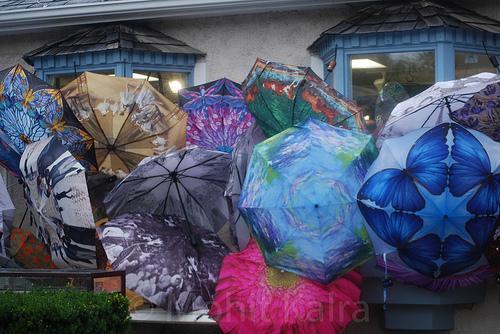How many bushes are shown?
Give a very brief answer. 1. 